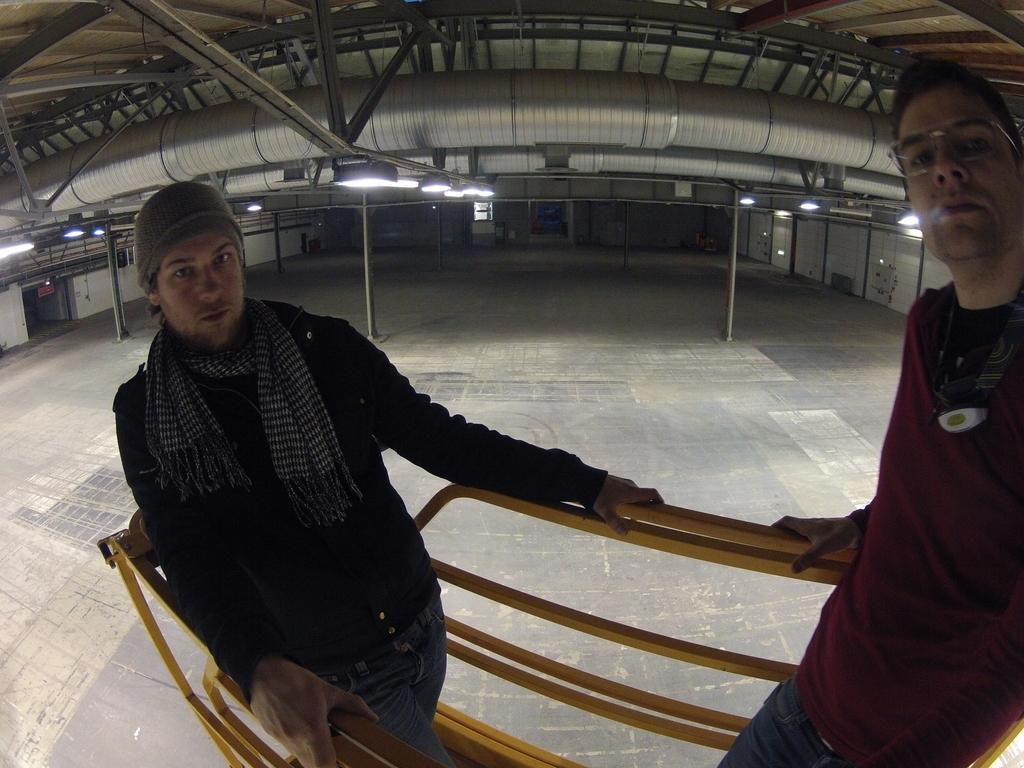Please provide a concise description of this image. In this picture there is a man who is wearing cap, jacket, scarf and jeans. Beside him there is another man who is wearing spectacle, t-shirt and jeans. Both of them are standing near to the fencing. In the back i can see many lights and ducts. At the top there is shed. On the left i can see the exit board. 